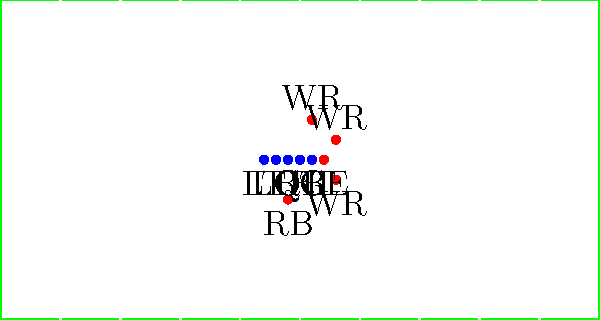Identify the offensive formation depicted in this diagram, which is commonly used in American football to create mismatches and exploit defensive weaknesses. To identify this offensive formation, let's analyze the player positions step-by-step:

1. The offensive line is in a standard configuration with 5 players (LT, LG, C, RG, RT).
2. There is one tight end (TE) positioned next to the right tackle.
3. There are three wide receivers (WR) spread out: one on each side and one in the slot on the right.
4. The quarterback (QB) is under center.
5. There is one running back (RB) positioned behind the quarterback.

This arrangement of players is characteristic of the "11 personnel" package, which includes:
- 1 running back
- 1 tight end
- 3 wide receivers

The specific formation shown here, with three receivers spread out and a tight end on the line, is known as the "Spread" formation. This formation is designed to stretch the defense horizontally and create favorable matchups for the offense.

The Spread formation is popular in modern football because it allows for both passing and running plays, keeping the defense guessing. It also forces the defense to defend the entire width of the field, potentially creating gaps for the offense to exploit.
Answer: Spread formation 